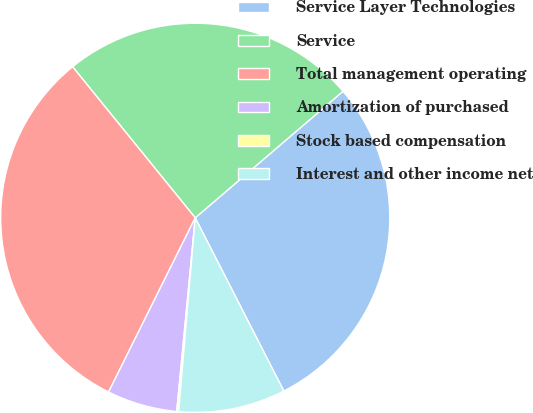Convert chart to OTSL. <chart><loc_0><loc_0><loc_500><loc_500><pie_chart><fcel>Service Layer Technologies<fcel>Service<fcel>Total management operating<fcel>Amortization of purchased<fcel>Stock based compensation<fcel>Interest and other income net<nl><fcel>28.75%<fcel>24.58%<fcel>31.8%<fcel>5.83%<fcel>0.16%<fcel>8.88%<nl></chart> 